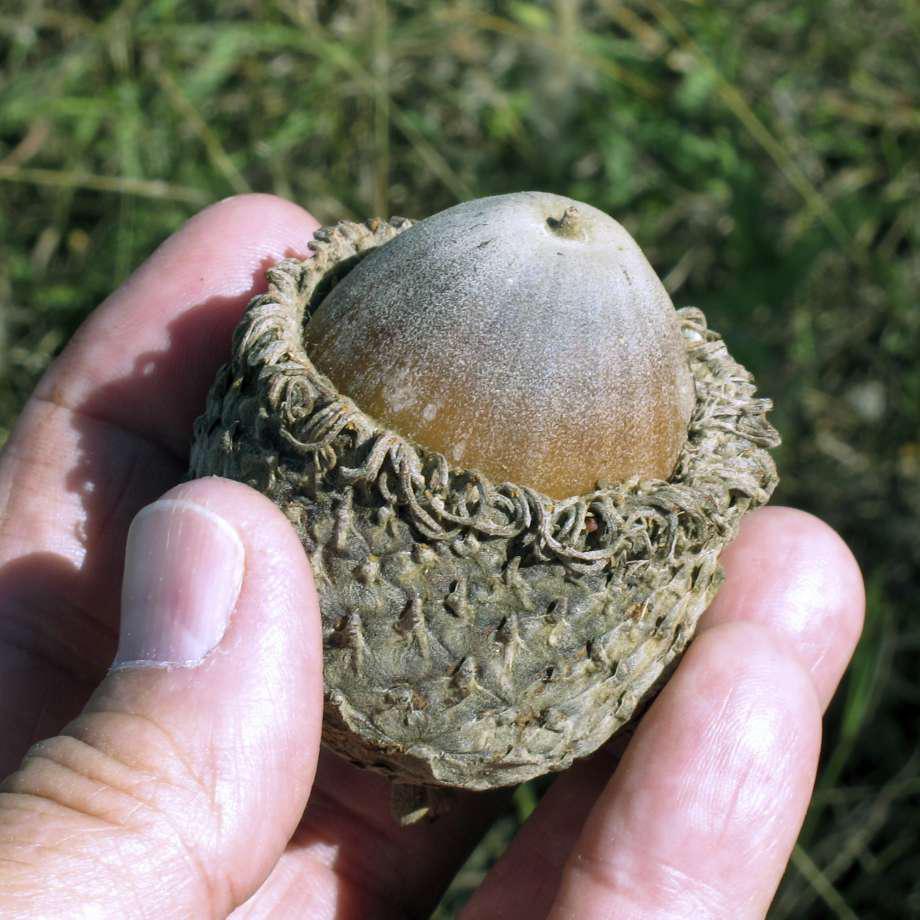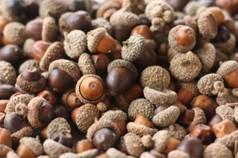The first image is the image on the left, the second image is the image on the right. Assess this claim about the two images: "There are at least 30 acorn bottoms sitting in the dirt with very little grass.". Correct or not? Answer yes or no. No. The first image is the image on the left, the second image is the image on the right. Examine the images to the left and right. Is the description "There are acorns laying in the dirt." accurate? Answer yes or no. No. 